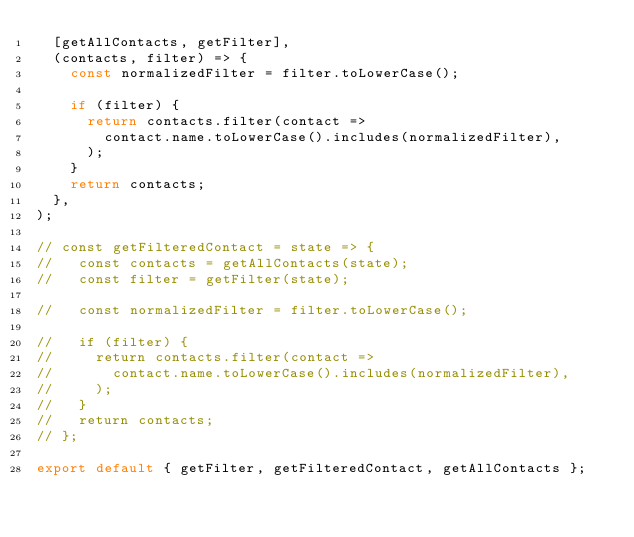<code> <loc_0><loc_0><loc_500><loc_500><_JavaScript_>  [getAllContacts, getFilter],
  (contacts, filter) => {
    const normalizedFilter = filter.toLowerCase();

    if (filter) {
      return contacts.filter(contact =>
        contact.name.toLowerCase().includes(normalizedFilter),
      );
    }
    return contacts;
  },
);

// const getFilteredContact = state => {
//   const contacts = getAllContacts(state);
//   const filter = getFilter(state);

//   const normalizedFilter = filter.toLowerCase();

//   if (filter) {
//     return contacts.filter(contact =>
//       contact.name.toLowerCase().includes(normalizedFilter),
//     );
//   }
//   return contacts;
// };

export default { getFilter, getFilteredContact, getAllContacts };</code> 